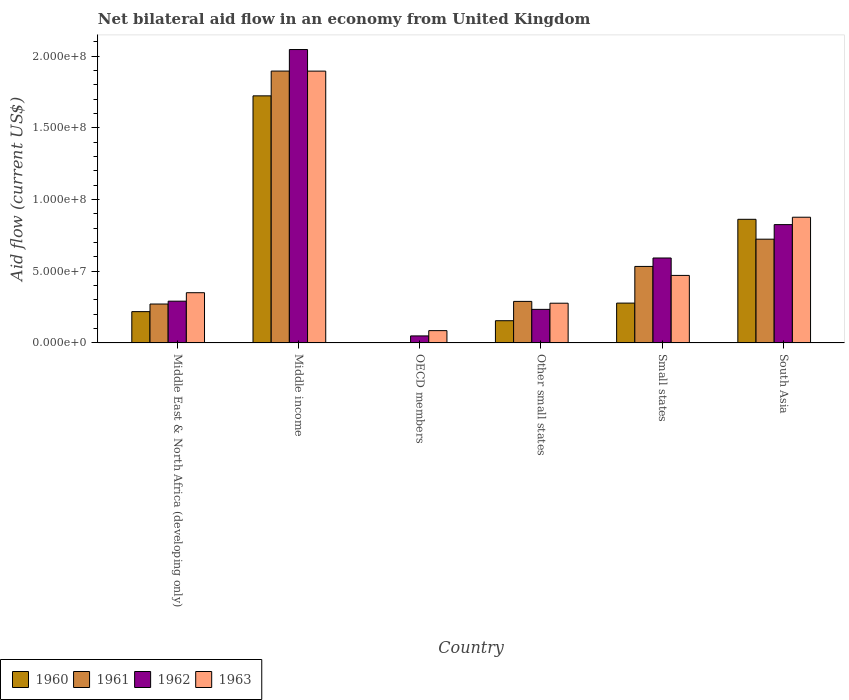How many groups of bars are there?
Your response must be concise. 6. Are the number of bars per tick equal to the number of legend labels?
Offer a very short reply. No. What is the label of the 4th group of bars from the left?
Make the answer very short. Other small states. In how many cases, is the number of bars for a given country not equal to the number of legend labels?
Provide a short and direct response. 1. What is the net bilateral aid flow in 1963 in OECD members?
Make the answer very short. 8.59e+06. Across all countries, what is the maximum net bilateral aid flow in 1962?
Give a very brief answer. 2.05e+08. Across all countries, what is the minimum net bilateral aid flow in 1963?
Provide a short and direct response. 8.59e+06. What is the total net bilateral aid flow in 1960 in the graph?
Keep it short and to the point. 3.24e+08. What is the difference between the net bilateral aid flow in 1961 in Middle income and that in Small states?
Ensure brevity in your answer.  1.36e+08. What is the difference between the net bilateral aid flow in 1960 in Middle East & North Africa (developing only) and the net bilateral aid flow in 1961 in Other small states?
Your answer should be compact. -7.15e+06. What is the average net bilateral aid flow in 1961 per country?
Make the answer very short. 6.19e+07. What is the difference between the net bilateral aid flow of/in 1960 and net bilateral aid flow of/in 1963 in Other small states?
Give a very brief answer. -1.22e+07. In how many countries, is the net bilateral aid flow in 1962 greater than 110000000 US$?
Offer a terse response. 1. What is the ratio of the net bilateral aid flow in 1960 in Other small states to that in Small states?
Offer a terse response. 0.56. Is the difference between the net bilateral aid flow in 1960 in Middle East & North Africa (developing only) and Middle income greater than the difference between the net bilateral aid flow in 1963 in Middle East & North Africa (developing only) and Middle income?
Keep it short and to the point. Yes. What is the difference between the highest and the second highest net bilateral aid flow in 1961?
Offer a very short reply. 1.17e+08. What is the difference between the highest and the lowest net bilateral aid flow in 1963?
Offer a very short reply. 1.81e+08. Is the sum of the net bilateral aid flow in 1962 in Other small states and Small states greater than the maximum net bilateral aid flow in 1963 across all countries?
Your answer should be very brief. No. Is it the case that in every country, the sum of the net bilateral aid flow in 1960 and net bilateral aid flow in 1962 is greater than the net bilateral aid flow in 1961?
Your answer should be very brief. Yes. Are the values on the major ticks of Y-axis written in scientific E-notation?
Your answer should be compact. Yes. Does the graph contain any zero values?
Offer a terse response. Yes. Does the graph contain grids?
Provide a short and direct response. No. How many legend labels are there?
Give a very brief answer. 4. How are the legend labels stacked?
Make the answer very short. Horizontal. What is the title of the graph?
Your answer should be very brief. Net bilateral aid flow in an economy from United Kingdom. Does "1994" appear as one of the legend labels in the graph?
Your answer should be very brief. No. What is the Aid flow (current US$) of 1960 in Middle East & North Africa (developing only)?
Your answer should be very brief. 2.18e+07. What is the Aid flow (current US$) of 1961 in Middle East & North Africa (developing only)?
Your answer should be compact. 2.72e+07. What is the Aid flow (current US$) of 1962 in Middle East & North Africa (developing only)?
Ensure brevity in your answer.  2.91e+07. What is the Aid flow (current US$) of 1963 in Middle East & North Africa (developing only)?
Your answer should be compact. 3.50e+07. What is the Aid flow (current US$) in 1960 in Middle income?
Offer a very short reply. 1.72e+08. What is the Aid flow (current US$) in 1961 in Middle income?
Offer a terse response. 1.90e+08. What is the Aid flow (current US$) of 1962 in Middle income?
Keep it short and to the point. 2.05e+08. What is the Aid flow (current US$) in 1963 in Middle income?
Provide a succinct answer. 1.90e+08. What is the Aid flow (current US$) of 1960 in OECD members?
Provide a succinct answer. 0. What is the Aid flow (current US$) in 1961 in OECD members?
Provide a short and direct response. 0. What is the Aid flow (current US$) in 1962 in OECD members?
Your answer should be compact. 4.90e+06. What is the Aid flow (current US$) in 1963 in OECD members?
Provide a short and direct response. 8.59e+06. What is the Aid flow (current US$) in 1960 in Other small states?
Ensure brevity in your answer.  1.55e+07. What is the Aid flow (current US$) in 1961 in Other small states?
Make the answer very short. 2.90e+07. What is the Aid flow (current US$) in 1962 in Other small states?
Offer a terse response. 2.34e+07. What is the Aid flow (current US$) of 1963 in Other small states?
Provide a short and direct response. 2.77e+07. What is the Aid flow (current US$) of 1960 in Small states?
Your answer should be compact. 2.78e+07. What is the Aid flow (current US$) in 1961 in Small states?
Offer a terse response. 5.34e+07. What is the Aid flow (current US$) of 1962 in Small states?
Provide a short and direct response. 5.93e+07. What is the Aid flow (current US$) of 1963 in Small states?
Offer a terse response. 4.71e+07. What is the Aid flow (current US$) in 1960 in South Asia?
Your answer should be very brief. 8.63e+07. What is the Aid flow (current US$) in 1961 in South Asia?
Offer a very short reply. 7.24e+07. What is the Aid flow (current US$) of 1962 in South Asia?
Make the answer very short. 8.26e+07. What is the Aid flow (current US$) of 1963 in South Asia?
Offer a terse response. 8.77e+07. Across all countries, what is the maximum Aid flow (current US$) of 1960?
Your answer should be very brief. 1.72e+08. Across all countries, what is the maximum Aid flow (current US$) of 1961?
Keep it short and to the point. 1.90e+08. Across all countries, what is the maximum Aid flow (current US$) in 1962?
Your answer should be compact. 2.05e+08. Across all countries, what is the maximum Aid flow (current US$) of 1963?
Provide a short and direct response. 1.90e+08. Across all countries, what is the minimum Aid flow (current US$) in 1960?
Provide a short and direct response. 0. Across all countries, what is the minimum Aid flow (current US$) in 1961?
Your answer should be compact. 0. Across all countries, what is the minimum Aid flow (current US$) of 1962?
Offer a terse response. 4.90e+06. Across all countries, what is the minimum Aid flow (current US$) of 1963?
Your response must be concise. 8.59e+06. What is the total Aid flow (current US$) in 1960 in the graph?
Offer a terse response. 3.24e+08. What is the total Aid flow (current US$) of 1961 in the graph?
Make the answer very short. 3.72e+08. What is the total Aid flow (current US$) in 1962 in the graph?
Your answer should be very brief. 4.04e+08. What is the total Aid flow (current US$) in 1963 in the graph?
Provide a succinct answer. 3.96e+08. What is the difference between the Aid flow (current US$) of 1960 in Middle East & North Africa (developing only) and that in Middle income?
Your answer should be very brief. -1.51e+08. What is the difference between the Aid flow (current US$) in 1961 in Middle East & North Africa (developing only) and that in Middle income?
Offer a very short reply. -1.63e+08. What is the difference between the Aid flow (current US$) of 1962 in Middle East & North Africa (developing only) and that in Middle income?
Offer a terse response. -1.76e+08. What is the difference between the Aid flow (current US$) in 1963 in Middle East & North Africa (developing only) and that in Middle income?
Offer a very short reply. -1.55e+08. What is the difference between the Aid flow (current US$) in 1962 in Middle East & North Africa (developing only) and that in OECD members?
Your response must be concise. 2.42e+07. What is the difference between the Aid flow (current US$) in 1963 in Middle East & North Africa (developing only) and that in OECD members?
Give a very brief answer. 2.65e+07. What is the difference between the Aid flow (current US$) in 1960 in Middle East & North Africa (developing only) and that in Other small states?
Provide a succinct answer. 6.33e+06. What is the difference between the Aid flow (current US$) in 1961 in Middle East & North Africa (developing only) and that in Other small states?
Your response must be concise. -1.84e+06. What is the difference between the Aid flow (current US$) of 1962 in Middle East & North Africa (developing only) and that in Other small states?
Provide a short and direct response. 5.71e+06. What is the difference between the Aid flow (current US$) in 1963 in Middle East & North Africa (developing only) and that in Other small states?
Provide a short and direct response. 7.33e+06. What is the difference between the Aid flow (current US$) in 1960 in Middle East & North Africa (developing only) and that in Small states?
Keep it short and to the point. -5.96e+06. What is the difference between the Aid flow (current US$) of 1961 in Middle East & North Africa (developing only) and that in Small states?
Provide a succinct answer. -2.62e+07. What is the difference between the Aid flow (current US$) in 1962 in Middle East & North Africa (developing only) and that in Small states?
Your answer should be compact. -3.01e+07. What is the difference between the Aid flow (current US$) of 1963 in Middle East & North Africa (developing only) and that in Small states?
Offer a terse response. -1.21e+07. What is the difference between the Aid flow (current US$) of 1960 in Middle East & North Africa (developing only) and that in South Asia?
Offer a terse response. -6.44e+07. What is the difference between the Aid flow (current US$) of 1961 in Middle East & North Africa (developing only) and that in South Asia?
Offer a very short reply. -4.52e+07. What is the difference between the Aid flow (current US$) in 1962 in Middle East & North Africa (developing only) and that in South Asia?
Provide a short and direct response. -5.34e+07. What is the difference between the Aid flow (current US$) of 1963 in Middle East & North Africa (developing only) and that in South Asia?
Provide a succinct answer. -5.27e+07. What is the difference between the Aid flow (current US$) of 1962 in Middle income and that in OECD members?
Provide a short and direct response. 2.00e+08. What is the difference between the Aid flow (current US$) in 1963 in Middle income and that in OECD members?
Offer a very short reply. 1.81e+08. What is the difference between the Aid flow (current US$) of 1960 in Middle income and that in Other small states?
Provide a short and direct response. 1.57e+08. What is the difference between the Aid flow (current US$) of 1961 in Middle income and that in Other small states?
Provide a succinct answer. 1.61e+08. What is the difference between the Aid flow (current US$) in 1962 in Middle income and that in Other small states?
Keep it short and to the point. 1.81e+08. What is the difference between the Aid flow (current US$) of 1963 in Middle income and that in Other small states?
Offer a very short reply. 1.62e+08. What is the difference between the Aid flow (current US$) of 1960 in Middle income and that in Small states?
Ensure brevity in your answer.  1.45e+08. What is the difference between the Aid flow (current US$) in 1961 in Middle income and that in Small states?
Provide a succinct answer. 1.36e+08. What is the difference between the Aid flow (current US$) in 1962 in Middle income and that in Small states?
Your response must be concise. 1.45e+08. What is the difference between the Aid flow (current US$) in 1963 in Middle income and that in Small states?
Provide a succinct answer. 1.43e+08. What is the difference between the Aid flow (current US$) in 1960 in Middle income and that in South Asia?
Keep it short and to the point. 8.61e+07. What is the difference between the Aid flow (current US$) in 1961 in Middle income and that in South Asia?
Ensure brevity in your answer.  1.17e+08. What is the difference between the Aid flow (current US$) in 1962 in Middle income and that in South Asia?
Offer a very short reply. 1.22e+08. What is the difference between the Aid flow (current US$) of 1963 in Middle income and that in South Asia?
Offer a terse response. 1.02e+08. What is the difference between the Aid flow (current US$) of 1962 in OECD members and that in Other small states?
Offer a very short reply. -1.85e+07. What is the difference between the Aid flow (current US$) in 1963 in OECD members and that in Other small states?
Offer a terse response. -1.91e+07. What is the difference between the Aid flow (current US$) in 1962 in OECD members and that in Small states?
Keep it short and to the point. -5.44e+07. What is the difference between the Aid flow (current US$) of 1963 in OECD members and that in Small states?
Offer a terse response. -3.85e+07. What is the difference between the Aid flow (current US$) in 1962 in OECD members and that in South Asia?
Keep it short and to the point. -7.77e+07. What is the difference between the Aid flow (current US$) in 1963 in OECD members and that in South Asia?
Ensure brevity in your answer.  -7.91e+07. What is the difference between the Aid flow (current US$) in 1960 in Other small states and that in Small states?
Give a very brief answer. -1.23e+07. What is the difference between the Aid flow (current US$) in 1961 in Other small states and that in Small states?
Make the answer very short. -2.44e+07. What is the difference between the Aid flow (current US$) in 1962 in Other small states and that in Small states?
Your response must be concise. -3.58e+07. What is the difference between the Aid flow (current US$) of 1963 in Other small states and that in Small states?
Your response must be concise. -1.94e+07. What is the difference between the Aid flow (current US$) in 1960 in Other small states and that in South Asia?
Ensure brevity in your answer.  -7.08e+07. What is the difference between the Aid flow (current US$) in 1961 in Other small states and that in South Asia?
Ensure brevity in your answer.  -4.34e+07. What is the difference between the Aid flow (current US$) of 1962 in Other small states and that in South Asia?
Provide a succinct answer. -5.91e+07. What is the difference between the Aid flow (current US$) in 1963 in Other small states and that in South Asia?
Offer a terse response. -6.00e+07. What is the difference between the Aid flow (current US$) in 1960 in Small states and that in South Asia?
Make the answer very short. -5.85e+07. What is the difference between the Aid flow (current US$) in 1961 in Small states and that in South Asia?
Your answer should be very brief. -1.90e+07. What is the difference between the Aid flow (current US$) in 1962 in Small states and that in South Asia?
Offer a terse response. -2.33e+07. What is the difference between the Aid flow (current US$) in 1963 in Small states and that in South Asia?
Ensure brevity in your answer.  -4.06e+07. What is the difference between the Aid flow (current US$) in 1960 in Middle East & North Africa (developing only) and the Aid flow (current US$) in 1961 in Middle income?
Provide a short and direct response. -1.68e+08. What is the difference between the Aid flow (current US$) of 1960 in Middle East & North Africa (developing only) and the Aid flow (current US$) of 1962 in Middle income?
Offer a very short reply. -1.83e+08. What is the difference between the Aid flow (current US$) of 1960 in Middle East & North Africa (developing only) and the Aid flow (current US$) of 1963 in Middle income?
Provide a short and direct response. -1.68e+08. What is the difference between the Aid flow (current US$) of 1961 in Middle East & North Africa (developing only) and the Aid flow (current US$) of 1962 in Middle income?
Provide a succinct answer. -1.78e+08. What is the difference between the Aid flow (current US$) in 1961 in Middle East & North Africa (developing only) and the Aid flow (current US$) in 1963 in Middle income?
Give a very brief answer. -1.63e+08. What is the difference between the Aid flow (current US$) of 1962 in Middle East & North Africa (developing only) and the Aid flow (current US$) of 1963 in Middle income?
Your response must be concise. -1.61e+08. What is the difference between the Aid flow (current US$) of 1960 in Middle East & North Africa (developing only) and the Aid flow (current US$) of 1962 in OECD members?
Your response must be concise. 1.69e+07. What is the difference between the Aid flow (current US$) in 1960 in Middle East & North Africa (developing only) and the Aid flow (current US$) in 1963 in OECD members?
Your answer should be compact. 1.32e+07. What is the difference between the Aid flow (current US$) in 1961 in Middle East & North Africa (developing only) and the Aid flow (current US$) in 1962 in OECD members?
Provide a succinct answer. 2.22e+07. What is the difference between the Aid flow (current US$) of 1961 in Middle East & North Africa (developing only) and the Aid flow (current US$) of 1963 in OECD members?
Your answer should be compact. 1.86e+07. What is the difference between the Aid flow (current US$) of 1962 in Middle East & North Africa (developing only) and the Aid flow (current US$) of 1963 in OECD members?
Keep it short and to the point. 2.06e+07. What is the difference between the Aid flow (current US$) of 1960 in Middle East & North Africa (developing only) and the Aid flow (current US$) of 1961 in Other small states?
Ensure brevity in your answer.  -7.15e+06. What is the difference between the Aid flow (current US$) in 1960 in Middle East & North Africa (developing only) and the Aid flow (current US$) in 1962 in Other small states?
Your answer should be compact. -1.59e+06. What is the difference between the Aid flow (current US$) in 1960 in Middle East & North Africa (developing only) and the Aid flow (current US$) in 1963 in Other small states?
Ensure brevity in your answer.  -5.88e+06. What is the difference between the Aid flow (current US$) of 1961 in Middle East & North Africa (developing only) and the Aid flow (current US$) of 1962 in Other small states?
Your answer should be very brief. 3.72e+06. What is the difference between the Aid flow (current US$) in 1961 in Middle East & North Africa (developing only) and the Aid flow (current US$) in 1963 in Other small states?
Provide a short and direct response. -5.70e+05. What is the difference between the Aid flow (current US$) in 1962 in Middle East & North Africa (developing only) and the Aid flow (current US$) in 1963 in Other small states?
Provide a short and direct response. 1.42e+06. What is the difference between the Aid flow (current US$) in 1960 in Middle East & North Africa (developing only) and the Aid flow (current US$) in 1961 in Small states?
Your answer should be compact. -3.15e+07. What is the difference between the Aid flow (current US$) in 1960 in Middle East & North Africa (developing only) and the Aid flow (current US$) in 1962 in Small states?
Your answer should be compact. -3.74e+07. What is the difference between the Aid flow (current US$) in 1960 in Middle East & North Africa (developing only) and the Aid flow (current US$) in 1963 in Small states?
Keep it short and to the point. -2.53e+07. What is the difference between the Aid flow (current US$) of 1961 in Middle East & North Africa (developing only) and the Aid flow (current US$) of 1962 in Small states?
Offer a terse response. -3.21e+07. What is the difference between the Aid flow (current US$) in 1961 in Middle East & North Africa (developing only) and the Aid flow (current US$) in 1963 in Small states?
Provide a succinct answer. -2.00e+07. What is the difference between the Aid flow (current US$) in 1962 in Middle East & North Africa (developing only) and the Aid flow (current US$) in 1963 in Small states?
Give a very brief answer. -1.80e+07. What is the difference between the Aid flow (current US$) in 1960 in Middle East & North Africa (developing only) and the Aid flow (current US$) in 1961 in South Asia?
Provide a short and direct response. -5.06e+07. What is the difference between the Aid flow (current US$) of 1960 in Middle East & North Africa (developing only) and the Aid flow (current US$) of 1962 in South Asia?
Offer a terse response. -6.07e+07. What is the difference between the Aid flow (current US$) in 1960 in Middle East & North Africa (developing only) and the Aid flow (current US$) in 1963 in South Asia?
Give a very brief answer. -6.59e+07. What is the difference between the Aid flow (current US$) in 1961 in Middle East & North Africa (developing only) and the Aid flow (current US$) in 1962 in South Asia?
Your answer should be very brief. -5.54e+07. What is the difference between the Aid flow (current US$) in 1961 in Middle East & North Africa (developing only) and the Aid flow (current US$) in 1963 in South Asia?
Offer a very short reply. -6.06e+07. What is the difference between the Aid flow (current US$) in 1962 in Middle East & North Africa (developing only) and the Aid flow (current US$) in 1963 in South Asia?
Make the answer very short. -5.86e+07. What is the difference between the Aid flow (current US$) of 1960 in Middle income and the Aid flow (current US$) of 1962 in OECD members?
Make the answer very short. 1.68e+08. What is the difference between the Aid flow (current US$) in 1960 in Middle income and the Aid flow (current US$) in 1963 in OECD members?
Provide a short and direct response. 1.64e+08. What is the difference between the Aid flow (current US$) of 1961 in Middle income and the Aid flow (current US$) of 1962 in OECD members?
Your answer should be compact. 1.85e+08. What is the difference between the Aid flow (current US$) in 1961 in Middle income and the Aid flow (current US$) in 1963 in OECD members?
Ensure brevity in your answer.  1.81e+08. What is the difference between the Aid flow (current US$) of 1962 in Middle income and the Aid flow (current US$) of 1963 in OECD members?
Offer a terse response. 1.96e+08. What is the difference between the Aid flow (current US$) in 1960 in Middle income and the Aid flow (current US$) in 1961 in Other small states?
Your response must be concise. 1.43e+08. What is the difference between the Aid flow (current US$) in 1960 in Middle income and the Aid flow (current US$) in 1962 in Other small states?
Make the answer very short. 1.49e+08. What is the difference between the Aid flow (current US$) of 1960 in Middle income and the Aid flow (current US$) of 1963 in Other small states?
Provide a succinct answer. 1.45e+08. What is the difference between the Aid flow (current US$) in 1961 in Middle income and the Aid flow (current US$) in 1962 in Other small states?
Your answer should be very brief. 1.66e+08. What is the difference between the Aid flow (current US$) in 1961 in Middle income and the Aid flow (current US$) in 1963 in Other small states?
Your answer should be compact. 1.62e+08. What is the difference between the Aid flow (current US$) in 1962 in Middle income and the Aid flow (current US$) in 1963 in Other small states?
Give a very brief answer. 1.77e+08. What is the difference between the Aid flow (current US$) in 1960 in Middle income and the Aid flow (current US$) in 1961 in Small states?
Give a very brief answer. 1.19e+08. What is the difference between the Aid flow (current US$) of 1960 in Middle income and the Aid flow (current US$) of 1962 in Small states?
Give a very brief answer. 1.13e+08. What is the difference between the Aid flow (current US$) in 1960 in Middle income and the Aid flow (current US$) in 1963 in Small states?
Give a very brief answer. 1.25e+08. What is the difference between the Aid flow (current US$) of 1961 in Middle income and the Aid flow (current US$) of 1962 in Small states?
Ensure brevity in your answer.  1.30e+08. What is the difference between the Aid flow (current US$) of 1961 in Middle income and the Aid flow (current US$) of 1963 in Small states?
Your answer should be very brief. 1.43e+08. What is the difference between the Aid flow (current US$) in 1962 in Middle income and the Aid flow (current US$) in 1963 in Small states?
Your response must be concise. 1.58e+08. What is the difference between the Aid flow (current US$) in 1960 in Middle income and the Aid flow (current US$) in 1962 in South Asia?
Offer a very short reply. 8.98e+07. What is the difference between the Aid flow (current US$) in 1960 in Middle income and the Aid flow (current US$) in 1963 in South Asia?
Provide a succinct answer. 8.47e+07. What is the difference between the Aid flow (current US$) of 1961 in Middle income and the Aid flow (current US$) of 1962 in South Asia?
Provide a short and direct response. 1.07e+08. What is the difference between the Aid flow (current US$) in 1961 in Middle income and the Aid flow (current US$) in 1963 in South Asia?
Your answer should be very brief. 1.02e+08. What is the difference between the Aid flow (current US$) in 1962 in Middle income and the Aid flow (current US$) in 1963 in South Asia?
Your response must be concise. 1.17e+08. What is the difference between the Aid flow (current US$) in 1962 in OECD members and the Aid flow (current US$) in 1963 in Other small states?
Give a very brief answer. -2.28e+07. What is the difference between the Aid flow (current US$) in 1962 in OECD members and the Aid flow (current US$) in 1963 in Small states?
Make the answer very short. -4.22e+07. What is the difference between the Aid flow (current US$) in 1962 in OECD members and the Aid flow (current US$) in 1963 in South Asia?
Offer a very short reply. -8.28e+07. What is the difference between the Aid flow (current US$) in 1960 in Other small states and the Aid flow (current US$) in 1961 in Small states?
Provide a short and direct response. -3.79e+07. What is the difference between the Aid flow (current US$) in 1960 in Other small states and the Aid flow (current US$) in 1962 in Small states?
Your answer should be very brief. -4.38e+07. What is the difference between the Aid flow (current US$) of 1960 in Other small states and the Aid flow (current US$) of 1963 in Small states?
Ensure brevity in your answer.  -3.16e+07. What is the difference between the Aid flow (current US$) in 1961 in Other small states and the Aid flow (current US$) in 1962 in Small states?
Ensure brevity in your answer.  -3.03e+07. What is the difference between the Aid flow (current US$) in 1961 in Other small states and the Aid flow (current US$) in 1963 in Small states?
Offer a very short reply. -1.81e+07. What is the difference between the Aid flow (current US$) of 1962 in Other small states and the Aid flow (current US$) of 1963 in Small states?
Ensure brevity in your answer.  -2.37e+07. What is the difference between the Aid flow (current US$) of 1960 in Other small states and the Aid flow (current US$) of 1961 in South Asia?
Your answer should be compact. -5.69e+07. What is the difference between the Aid flow (current US$) in 1960 in Other small states and the Aid flow (current US$) in 1962 in South Asia?
Provide a short and direct response. -6.70e+07. What is the difference between the Aid flow (current US$) of 1960 in Other small states and the Aid flow (current US$) of 1963 in South Asia?
Your response must be concise. -7.22e+07. What is the difference between the Aid flow (current US$) in 1961 in Other small states and the Aid flow (current US$) in 1962 in South Asia?
Ensure brevity in your answer.  -5.36e+07. What is the difference between the Aid flow (current US$) of 1961 in Other small states and the Aid flow (current US$) of 1963 in South Asia?
Make the answer very short. -5.87e+07. What is the difference between the Aid flow (current US$) of 1962 in Other small states and the Aid flow (current US$) of 1963 in South Asia?
Your response must be concise. -6.43e+07. What is the difference between the Aid flow (current US$) in 1960 in Small states and the Aid flow (current US$) in 1961 in South Asia?
Ensure brevity in your answer.  -4.46e+07. What is the difference between the Aid flow (current US$) in 1960 in Small states and the Aid flow (current US$) in 1962 in South Asia?
Make the answer very short. -5.48e+07. What is the difference between the Aid flow (current US$) of 1960 in Small states and the Aid flow (current US$) of 1963 in South Asia?
Make the answer very short. -5.99e+07. What is the difference between the Aid flow (current US$) of 1961 in Small states and the Aid flow (current US$) of 1962 in South Asia?
Make the answer very short. -2.92e+07. What is the difference between the Aid flow (current US$) in 1961 in Small states and the Aid flow (current US$) in 1963 in South Asia?
Your answer should be compact. -3.43e+07. What is the difference between the Aid flow (current US$) of 1962 in Small states and the Aid flow (current US$) of 1963 in South Asia?
Provide a short and direct response. -2.84e+07. What is the average Aid flow (current US$) in 1960 per country?
Give a very brief answer. 5.40e+07. What is the average Aid flow (current US$) in 1961 per country?
Make the answer very short. 6.19e+07. What is the average Aid flow (current US$) of 1962 per country?
Make the answer very short. 6.73e+07. What is the average Aid flow (current US$) in 1963 per country?
Provide a succinct answer. 6.60e+07. What is the difference between the Aid flow (current US$) of 1960 and Aid flow (current US$) of 1961 in Middle East & North Africa (developing only)?
Your answer should be very brief. -5.31e+06. What is the difference between the Aid flow (current US$) of 1960 and Aid flow (current US$) of 1962 in Middle East & North Africa (developing only)?
Offer a very short reply. -7.30e+06. What is the difference between the Aid flow (current US$) in 1960 and Aid flow (current US$) in 1963 in Middle East & North Africa (developing only)?
Ensure brevity in your answer.  -1.32e+07. What is the difference between the Aid flow (current US$) of 1961 and Aid flow (current US$) of 1962 in Middle East & North Africa (developing only)?
Make the answer very short. -1.99e+06. What is the difference between the Aid flow (current US$) of 1961 and Aid flow (current US$) of 1963 in Middle East & North Africa (developing only)?
Give a very brief answer. -7.90e+06. What is the difference between the Aid flow (current US$) of 1962 and Aid flow (current US$) of 1963 in Middle East & North Africa (developing only)?
Give a very brief answer. -5.91e+06. What is the difference between the Aid flow (current US$) in 1960 and Aid flow (current US$) in 1961 in Middle income?
Keep it short and to the point. -1.73e+07. What is the difference between the Aid flow (current US$) in 1960 and Aid flow (current US$) in 1962 in Middle income?
Offer a terse response. -3.23e+07. What is the difference between the Aid flow (current US$) of 1960 and Aid flow (current US$) of 1963 in Middle income?
Provide a succinct answer. -1.73e+07. What is the difference between the Aid flow (current US$) in 1961 and Aid flow (current US$) in 1962 in Middle income?
Give a very brief answer. -1.50e+07. What is the difference between the Aid flow (current US$) in 1962 and Aid flow (current US$) in 1963 in Middle income?
Offer a very short reply. 1.50e+07. What is the difference between the Aid flow (current US$) of 1962 and Aid flow (current US$) of 1963 in OECD members?
Make the answer very short. -3.69e+06. What is the difference between the Aid flow (current US$) of 1960 and Aid flow (current US$) of 1961 in Other small states?
Make the answer very short. -1.35e+07. What is the difference between the Aid flow (current US$) of 1960 and Aid flow (current US$) of 1962 in Other small states?
Offer a terse response. -7.92e+06. What is the difference between the Aid flow (current US$) in 1960 and Aid flow (current US$) in 1963 in Other small states?
Make the answer very short. -1.22e+07. What is the difference between the Aid flow (current US$) in 1961 and Aid flow (current US$) in 1962 in Other small states?
Provide a short and direct response. 5.56e+06. What is the difference between the Aid flow (current US$) in 1961 and Aid flow (current US$) in 1963 in Other small states?
Provide a succinct answer. 1.27e+06. What is the difference between the Aid flow (current US$) in 1962 and Aid flow (current US$) in 1963 in Other small states?
Keep it short and to the point. -4.29e+06. What is the difference between the Aid flow (current US$) in 1960 and Aid flow (current US$) in 1961 in Small states?
Your response must be concise. -2.56e+07. What is the difference between the Aid flow (current US$) in 1960 and Aid flow (current US$) in 1962 in Small states?
Offer a very short reply. -3.15e+07. What is the difference between the Aid flow (current US$) in 1960 and Aid flow (current US$) in 1963 in Small states?
Keep it short and to the point. -1.93e+07. What is the difference between the Aid flow (current US$) of 1961 and Aid flow (current US$) of 1962 in Small states?
Ensure brevity in your answer.  -5.89e+06. What is the difference between the Aid flow (current US$) in 1961 and Aid flow (current US$) in 1963 in Small states?
Your answer should be compact. 6.26e+06. What is the difference between the Aid flow (current US$) of 1962 and Aid flow (current US$) of 1963 in Small states?
Provide a short and direct response. 1.22e+07. What is the difference between the Aid flow (current US$) in 1960 and Aid flow (current US$) in 1961 in South Asia?
Offer a very short reply. 1.39e+07. What is the difference between the Aid flow (current US$) in 1960 and Aid flow (current US$) in 1962 in South Asia?
Ensure brevity in your answer.  3.70e+06. What is the difference between the Aid flow (current US$) in 1960 and Aid flow (current US$) in 1963 in South Asia?
Ensure brevity in your answer.  -1.45e+06. What is the difference between the Aid flow (current US$) in 1961 and Aid flow (current US$) in 1962 in South Asia?
Provide a succinct answer. -1.02e+07. What is the difference between the Aid flow (current US$) of 1961 and Aid flow (current US$) of 1963 in South Asia?
Provide a short and direct response. -1.53e+07. What is the difference between the Aid flow (current US$) of 1962 and Aid flow (current US$) of 1963 in South Asia?
Offer a very short reply. -5.15e+06. What is the ratio of the Aid flow (current US$) in 1960 in Middle East & North Africa (developing only) to that in Middle income?
Keep it short and to the point. 0.13. What is the ratio of the Aid flow (current US$) of 1961 in Middle East & North Africa (developing only) to that in Middle income?
Provide a succinct answer. 0.14. What is the ratio of the Aid flow (current US$) in 1962 in Middle East & North Africa (developing only) to that in Middle income?
Keep it short and to the point. 0.14. What is the ratio of the Aid flow (current US$) of 1963 in Middle East & North Africa (developing only) to that in Middle income?
Your answer should be compact. 0.18. What is the ratio of the Aid flow (current US$) in 1962 in Middle East & North Africa (developing only) to that in OECD members?
Provide a short and direct response. 5.95. What is the ratio of the Aid flow (current US$) of 1963 in Middle East & North Africa (developing only) to that in OECD members?
Keep it short and to the point. 4.08. What is the ratio of the Aid flow (current US$) of 1960 in Middle East & North Africa (developing only) to that in Other small states?
Your answer should be compact. 1.41. What is the ratio of the Aid flow (current US$) of 1961 in Middle East & North Africa (developing only) to that in Other small states?
Provide a short and direct response. 0.94. What is the ratio of the Aid flow (current US$) of 1962 in Middle East & North Africa (developing only) to that in Other small states?
Your answer should be very brief. 1.24. What is the ratio of the Aid flow (current US$) in 1963 in Middle East & North Africa (developing only) to that in Other small states?
Offer a terse response. 1.26. What is the ratio of the Aid flow (current US$) in 1960 in Middle East & North Africa (developing only) to that in Small states?
Provide a short and direct response. 0.79. What is the ratio of the Aid flow (current US$) in 1961 in Middle East & North Africa (developing only) to that in Small states?
Keep it short and to the point. 0.51. What is the ratio of the Aid flow (current US$) of 1962 in Middle East & North Africa (developing only) to that in Small states?
Your response must be concise. 0.49. What is the ratio of the Aid flow (current US$) of 1963 in Middle East & North Africa (developing only) to that in Small states?
Ensure brevity in your answer.  0.74. What is the ratio of the Aid flow (current US$) in 1960 in Middle East & North Africa (developing only) to that in South Asia?
Give a very brief answer. 0.25. What is the ratio of the Aid flow (current US$) of 1962 in Middle East & North Africa (developing only) to that in South Asia?
Offer a terse response. 0.35. What is the ratio of the Aid flow (current US$) in 1963 in Middle East & North Africa (developing only) to that in South Asia?
Provide a short and direct response. 0.4. What is the ratio of the Aid flow (current US$) in 1962 in Middle income to that in OECD members?
Your response must be concise. 41.78. What is the ratio of the Aid flow (current US$) in 1963 in Middle income to that in OECD members?
Provide a succinct answer. 22.08. What is the ratio of the Aid flow (current US$) in 1960 in Middle income to that in Other small states?
Your answer should be very brief. 11.12. What is the ratio of the Aid flow (current US$) in 1961 in Middle income to that in Other small states?
Offer a very short reply. 6.54. What is the ratio of the Aid flow (current US$) of 1962 in Middle income to that in Other small states?
Keep it short and to the point. 8.74. What is the ratio of the Aid flow (current US$) in 1963 in Middle income to that in Other small states?
Your answer should be very brief. 6.84. What is the ratio of the Aid flow (current US$) in 1960 in Middle income to that in Small states?
Provide a succinct answer. 6.2. What is the ratio of the Aid flow (current US$) in 1961 in Middle income to that in Small states?
Ensure brevity in your answer.  3.55. What is the ratio of the Aid flow (current US$) of 1962 in Middle income to that in Small states?
Provide a short and direct response. 3.45. What is the ratio of the Aid flow (current US$) of 1963 in Middle income to that in Small states?
Keep it short and to the point. 4.03. What is the ratio of the Aid flow (current US$) in 1960 in Middle income to that in South Asia?
Keep it short and to the point. 2. What is the ratio of the Aid flow (current US$) in 1961 in Middle income to that in South Asia?
Your answer should be very brief. 2.62. What is the ratio of the Aid flow (current US$) in 1962 in Middle income to that in South Asia?
Your answer should be very brief. 2.48. What is the ratio of the Aid flow (current US$) in 1963 in Middle income to that in South Asia?
Make the answer very short. 2.16. What is the ratio of the Aid flow (current US$) of 1962 in OECD members to that in Other small states?
Give a very brief answer. 0.21. What is the ratio of the Aid flow (current US$) in 1963 in OECD members to that in Other small states?
Give a very brief answer. 0.31. What is the ratio of the Aid flow (current US$) of 1962 in OECD members to that in Small states?
Give a very brief answer. 0.08. What is the ratio of the Aid flow (current US$) in 1963 in OECD members to that in Small states?
Your answer should be very brief. 0.18. What is the ratio of the Aid flow (current US$) in 1962 in OECD members to that in South Asia?
Your answer should be compact. 0.06. What is the ratio of the Aid flow (current US$) of 1963 in OECD members to that in South Asia?
Your answer should be compact. 0.1. What is the ratio of the Aid flow (current US$) of 1960 in Other small states to that in Small states?
Make the answer very short. 0.56. What is the ratio of the Aid flow (current US$) of 1961 in Other small states to that in Small states?
Provide a succinct answer. 0.54. What is the ratio of the Aid flow (current US$) of 1962 in Other small states to that in Small states?
Provide a succinct answer. 0.4. What is the ratio of the Aid flow (current US$) in 1963 in Other small states to that in Small states?
Make the answer very short. 0.59. What is the ratio of the Aid flow (current US$) of 1960 in Other small states to that in South Asia?
Your answer should be very brief. 0.18. What is the ratio of the Aid flow (current US$) of 1961 in Other small states to that in South Asia?
Your response must be concise. 0.4. What is the ratio of the Aid flow (current US$) in 1962 in Other small states to that in South Asia?
Offer a terse response. 0.28. What is the ratio of the Aid flow (current US$) of 1963 in Other small states to that in South Asia?
Your answer should be very brief. 0.32. What is the ratio of the Aid flow (current US$) in 1960 in Small states to that in South Asia?
Provide a short and direct response. 0.32. What is the ratio of the Aid flow (current US$) in 1961 in Small states to that in South Asia?
Offer a very short reply. 0.74. What is the ratio of the Aid flow (current US$) of 1962 in Small states to that in South Asia?
Provide a succinct answer. 0.72. What is the ratio of the Aid flow (current US$) in 1963 in Small states to that in South Asia?
Keep it short and to the point. 0.54. What is the difference between the highest and the second highest Aid flow (current US$) in 1960?
Provide a succinct answer. 8.61e+07. What is the difference between the highest and the second highest Aid flow (current US$) in 1961?
Your answer should be very brief. 1.17e+08. What is the difference between the highest and the second highest Aid flow (current US$) in 1962?
Offer a very short reply. 1.22e+08. What is the difference between the highest and the second highest Aid flow (current US$) of 1963?
Give a very brief answer. 1.02e+08. What is the difference between the highest and the lowest Aid flow (current US$) of 1960?
Provide a short and direct response. 1.72e+08. What is the difference between the highest and the lowest Aid flow (current US$) of 1961?
Offer a very short reply. 1.90e+08. What is the difference between the highest and the lowest Aid flow (current US$) of 1962?
Ensure brevity in your answer.  2.00e+08. What is the difference between the highest and the lowest Aid flow (current US$) of 1963?
Your answer should be compact. 1.81e+08. 